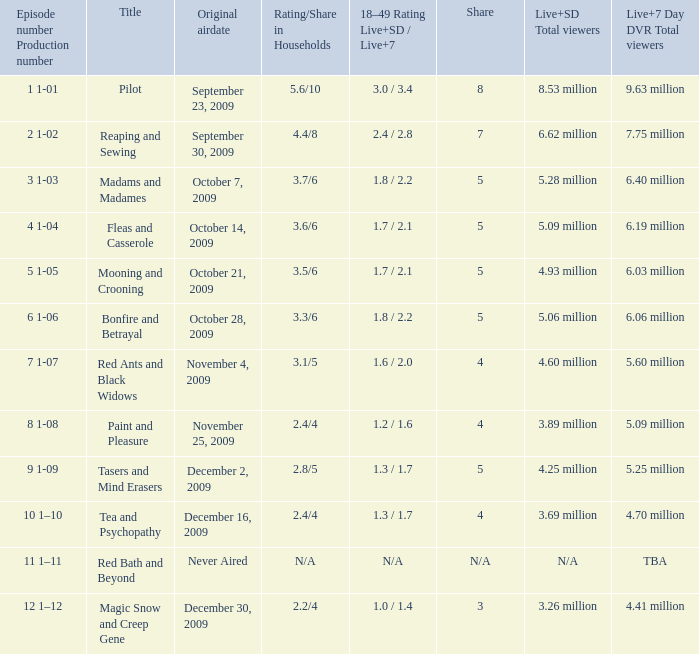What is the total number of viewers, including both live and sd, for the episode that had an 8 share? 9.63 million. 